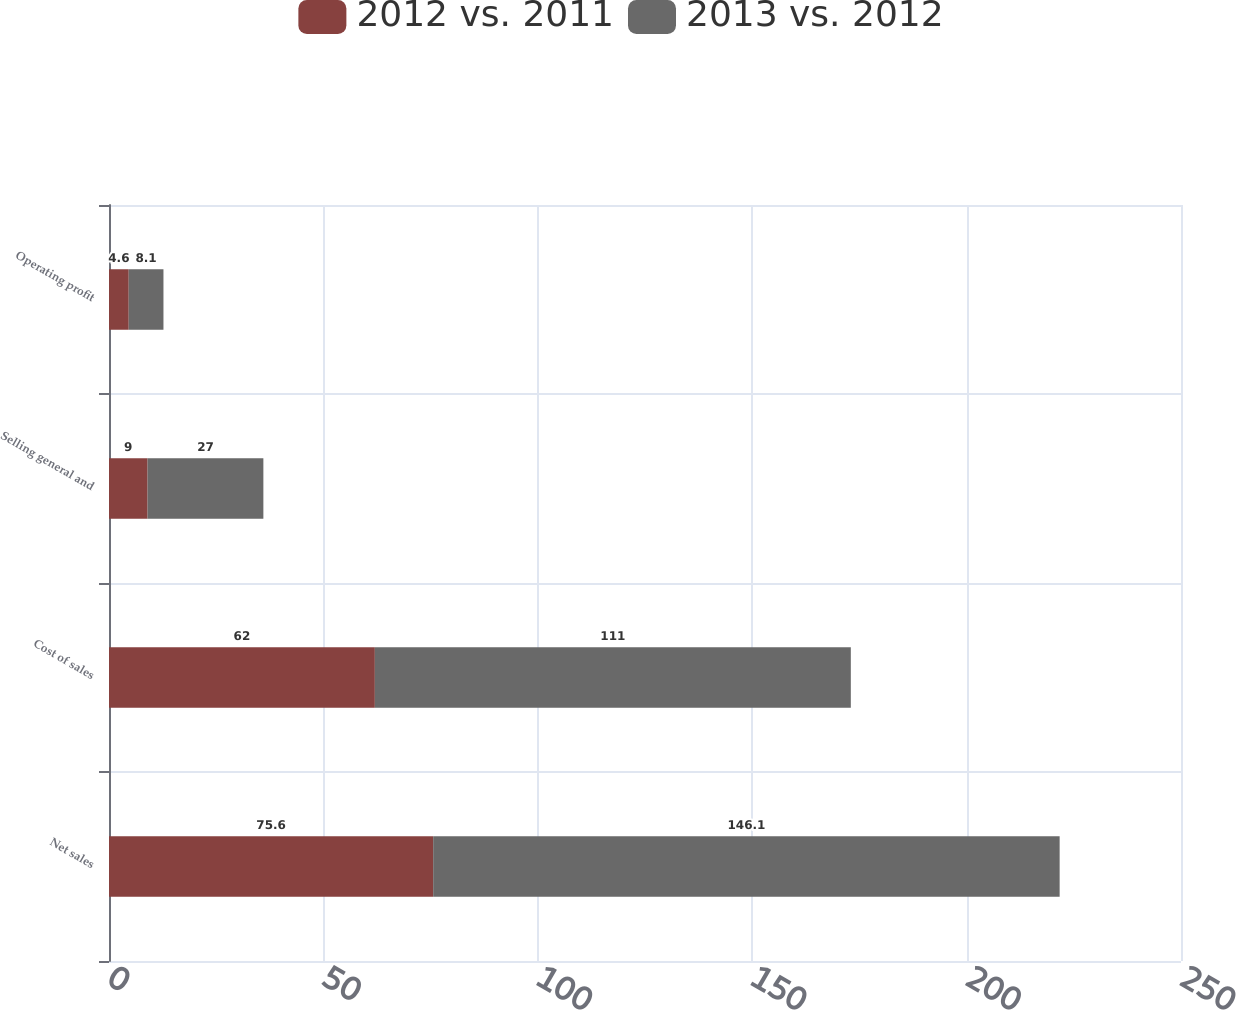Convert chart to OTSL. <chart><loc_0><loc_0><loc_500><loc_500><stacked_bar_chart><ecel><fcel>Net sales<fcel>Cost of sales<fcel>Selling general and<fcel>Operating profit<nl><fcel>2012 vs. 2011<fcel>75.6<fcel>62<fcel>9<fcel>4.6<nl><fcel>2013 vs. 2012<fcel>146.1<fcel>111<fcel>27<fcel>8.1<nl></chart> 